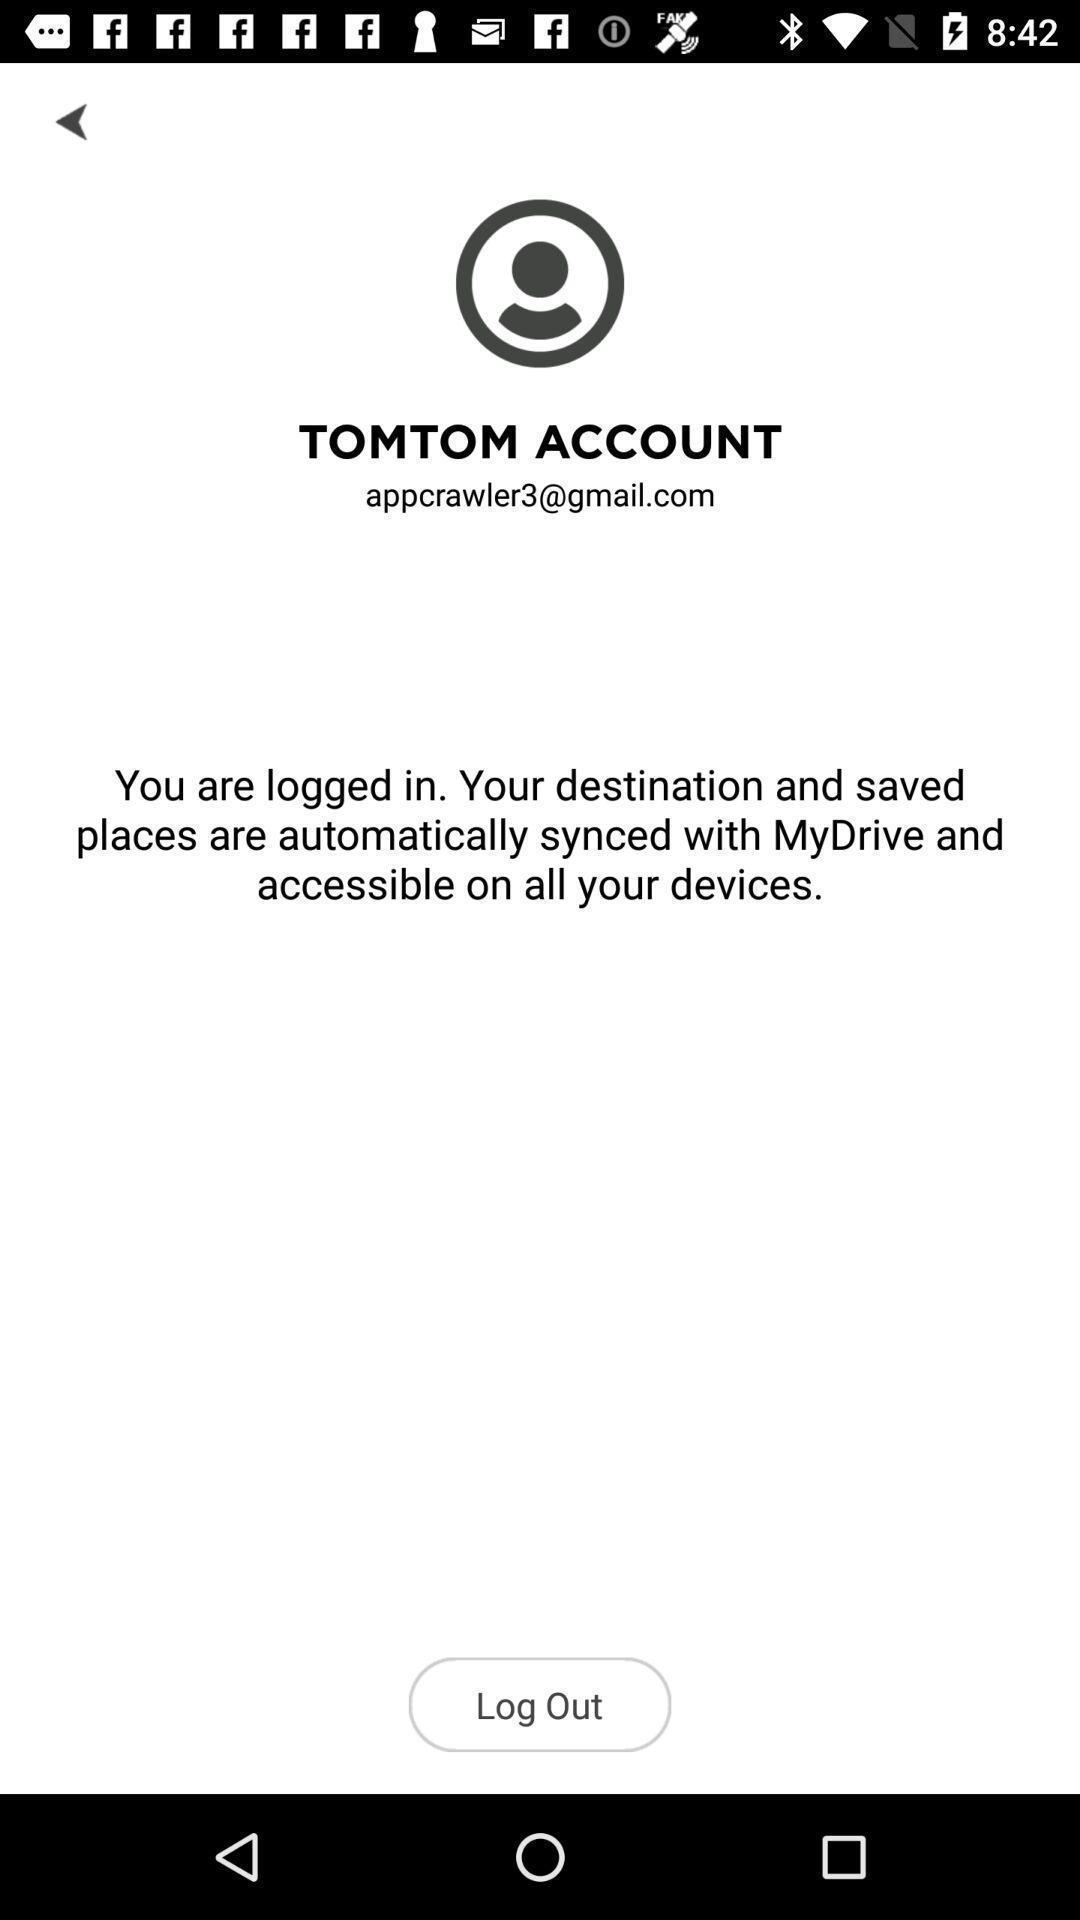Provide a detailed account of this screenshot. Page showing information about account with logout option. 